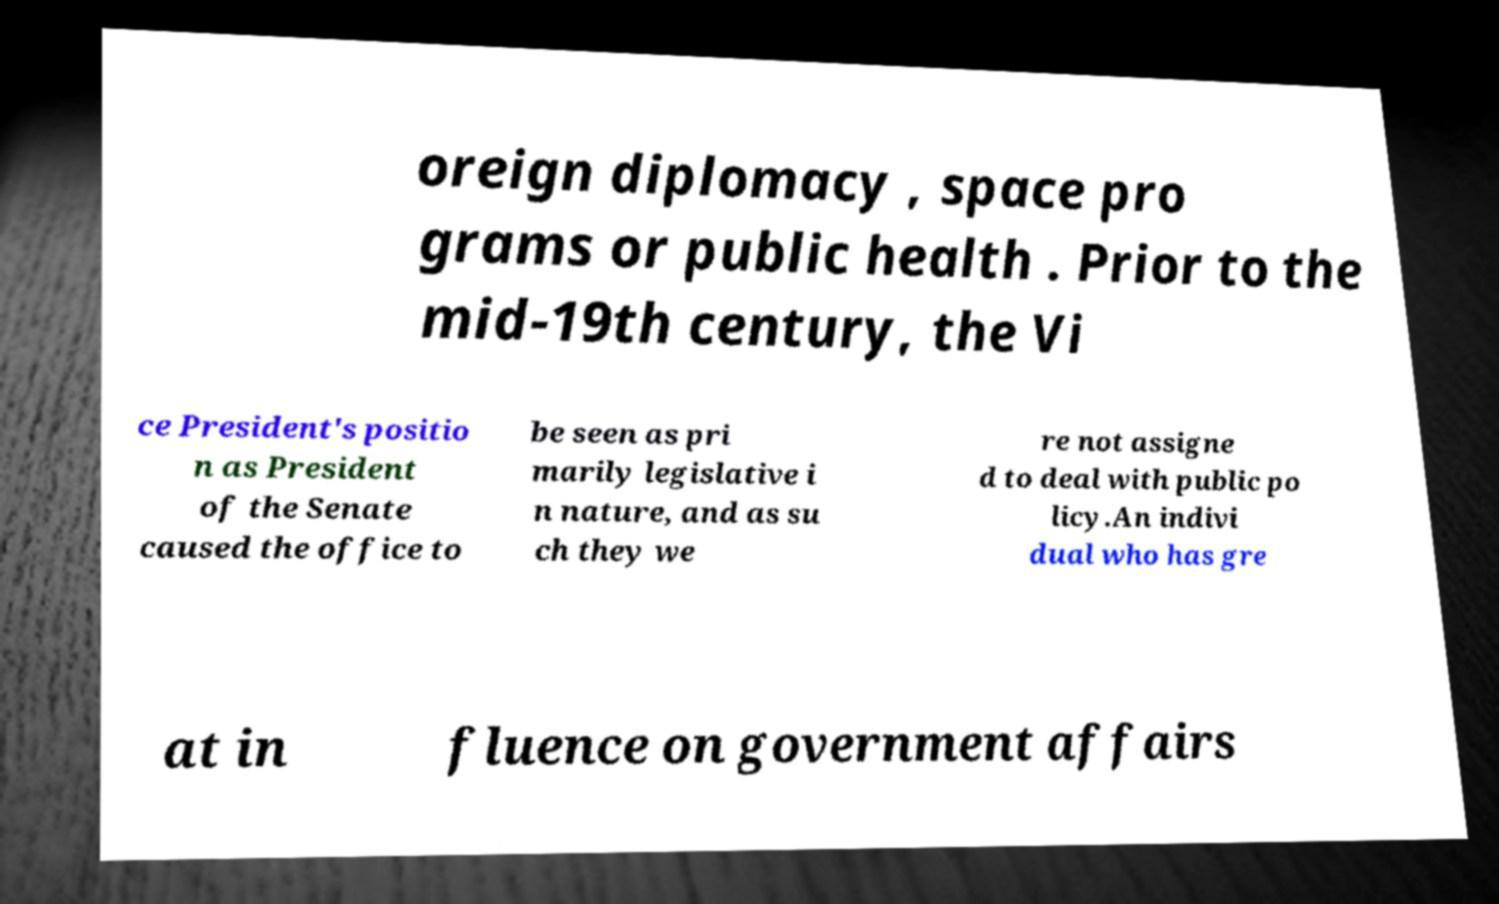Could you assist in decoding the text presented in this image and type it out clearly? oreign diplomacy , space pro grams or public health . Prior to the mid-19th century, the Vi ce President's positio n as President of the Senate caused the office to be seen as pri marily legislative i n nature, and as su ch they we re not assigne d to deal with public po licy.An indivi dual who has gre at in fluence on government affairs 